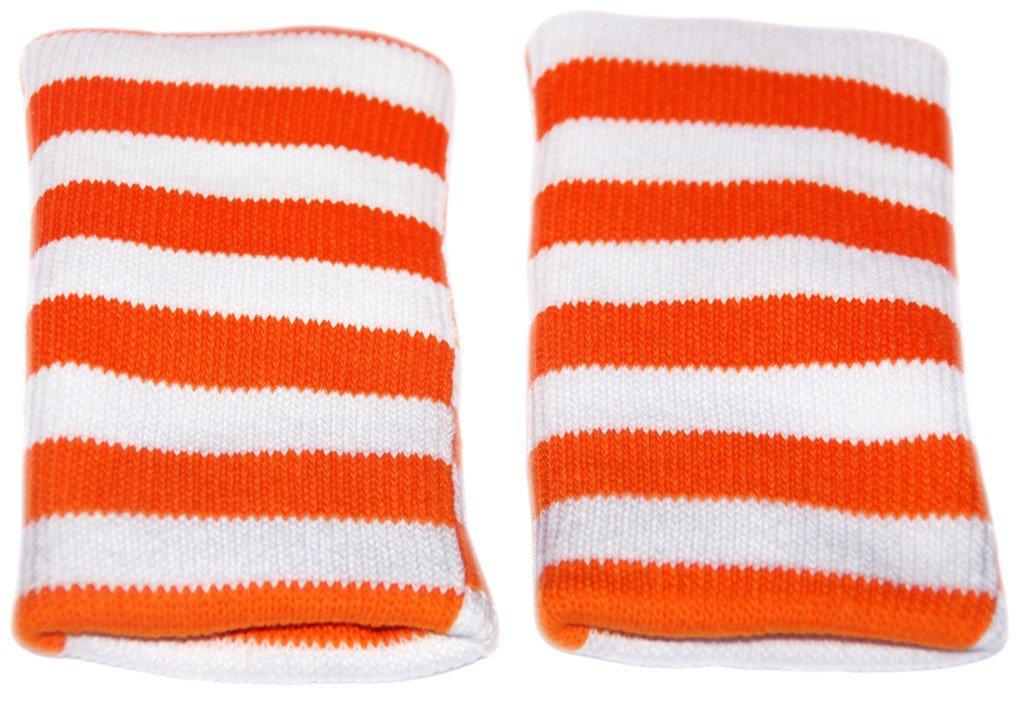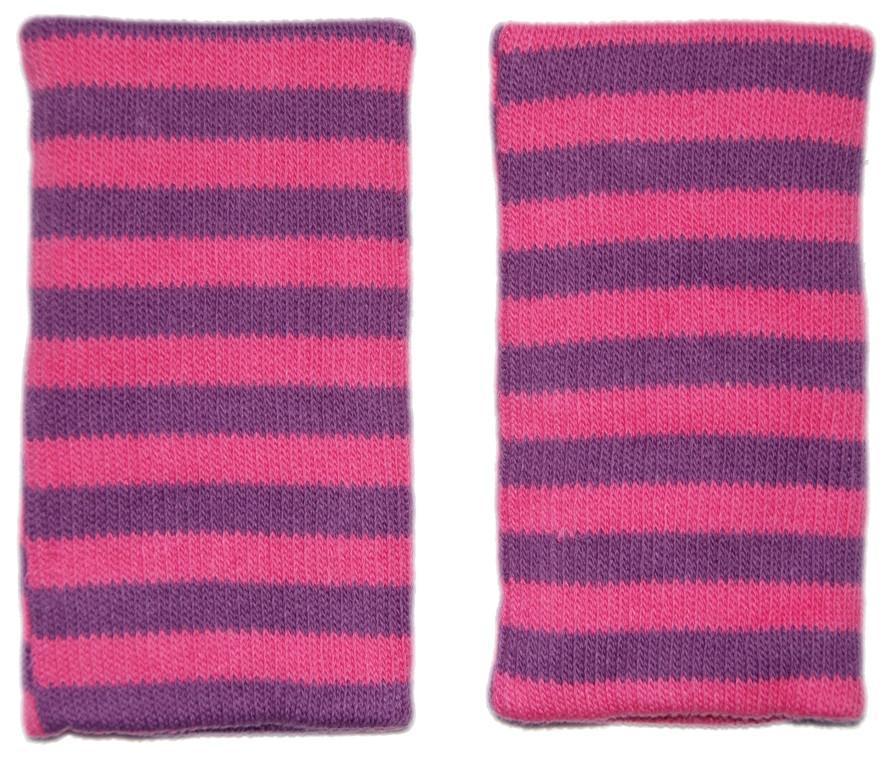The first image is the image on the left, the second image is the image on the right. Analyze the images presented: Is the assertion "The left and right image contains the same number of soft knit wrist guards." valid? Answer yes or no. Yes. The first image is the image on the left, the second image is the image on the right. Evaluate the accuracy of this statement regarding the images: "One image shows a pair of toddler knees kneeling on a wood floor and wearing colored knee pads with paw prints on them.". Is it true? Answer yes or no. No. 